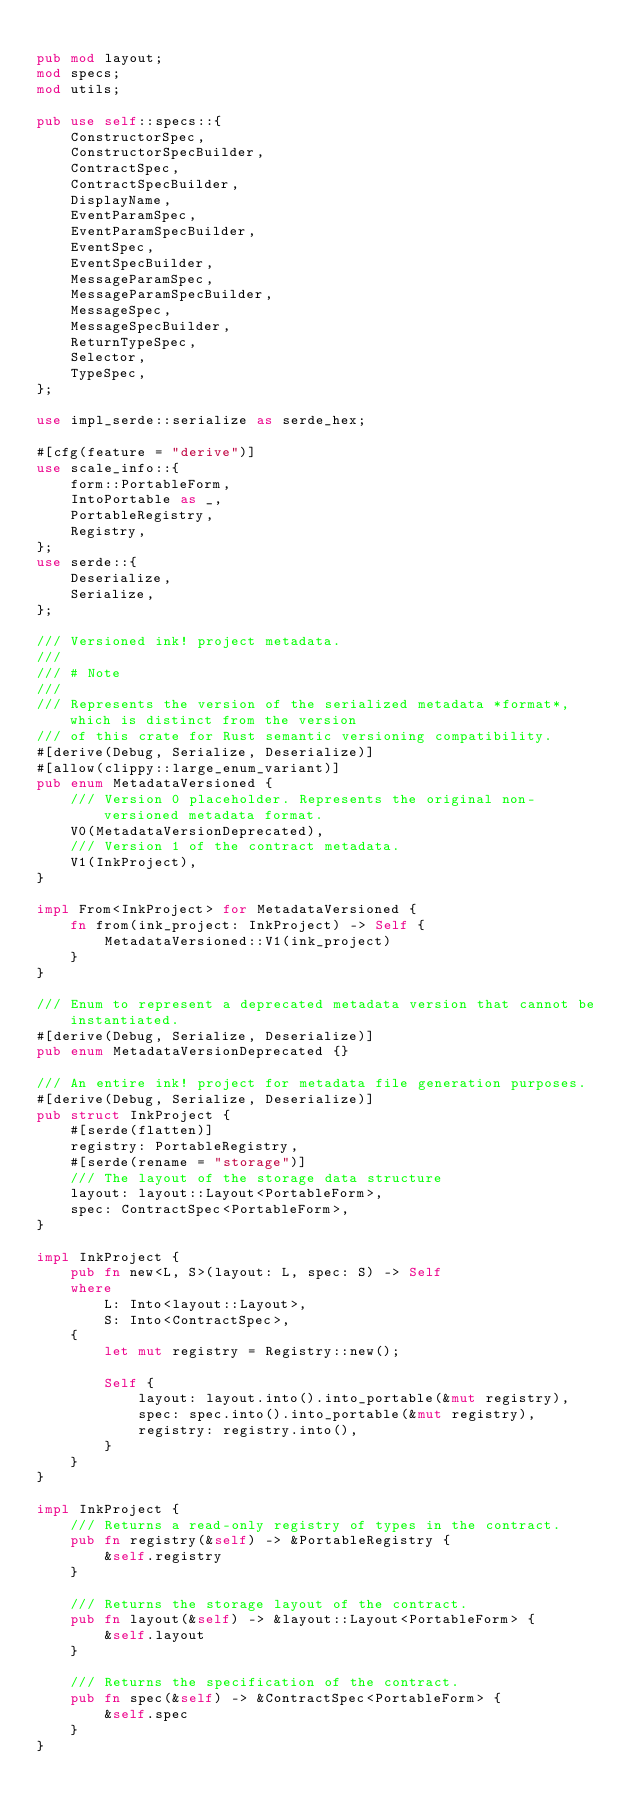Convert code to text. <code><loc_0><loc_0><loc_500><loc_500><_Rust_>
pub mod layout;
mod specs;
mod utils;

pub use self::specs::{
    ConstructorSpec,
    ConstructorSpecBuilder,
    ContractSpec,
    ContractSpecBuilder,
    DisplayName,
    EventParamSpec,
    EventParamSpecBuilder,
    EventSpec,
    EventSpecBuilder,
    MessageParamSpec,
    MessageParamSpecBuilder,
    MessageSpec,
    MessageSpecBuilder,
    ReturnTypeSpec,
    Selector,
    TypeSpec,
};

use impl_serde::serialize as serde_hex;

#[cfg(feature = "derive")]
use scale_info::{
    form::PortableForm,
    IntoPortable as _,
    PortableRegistry,
    Registry,
};
use serde::{
    Deserialize,
    Serialize,
};

/// Versioned ink! project metadata.
///
/// # Note
///
/// Represents the version of the serialized metadata *format*, which is distinct from the version
/// of this crate for Rust semantic versioning compatibility.
#[derive(Debug, Serialize, Deserialize)]
#[allow(clippy::large_enum_variant)]
pub enum MetadataVersioned {
    /// Version 0 placeholder. Represents the original non-versioned metadata format.
    V0(MetadataVersionDeprecated),
    /// Version 1 of the contract metadata.
    V1(InkProject),
}

impl From<InkProject> for MetadataVersioned {
    fn from(ink_project: InkProject) -> Self {
        MetadataVersioned::V1(ink_project)
    }
}

/// Enum to represent a deprecated metadata version that cannot be instantiated.
#[derive(Debug, Serialize, Deserialize)]
pub enum MetadataVersionDeprecated {}

/// An entire ink! project for metadata file generation purposes.
#[derive(Debug, Serialize, Deserialize)]
pub struct InkProject {
    #[serde(flatten)]
    registry: PortableRegistry,
    #[serde(rename = "storage")]
    /// The layout of the storage data structure
    layout: layout::Layout<PortableForm>,
    spec: ContractSpec<PortableForm>,
}

impl InkProject {
    pub fn new<L, S>(layout: L, spec: S) -> Self
    where
        L: Into<layout::Layout>,
        S: Into<ContractSpec>,
    {
        let mut registry = Registry::new();

        Self {
            layout: layout.into().into_portable(&mut registry),
            spec: spec.into().into_portable(&mut registry),
            registry: registry.into(),
        }
    }
}

impl InkProject {
    /// Returns a read-only registry of types in the contract.
    pub fn registry(&self) -> &PortableRegistry {
        &self.registry
    }

    /// Returns the storage layout of the contract.
    pub fn layout(&self) -> &layout::Layout<PortableForm> {
        &self.layout
    }

    /// Returns the specification of the contract.
    pub fn spec(&self) -> &ContractSpec<PortableForm> {
        &self.spec
    }
}
</code> 